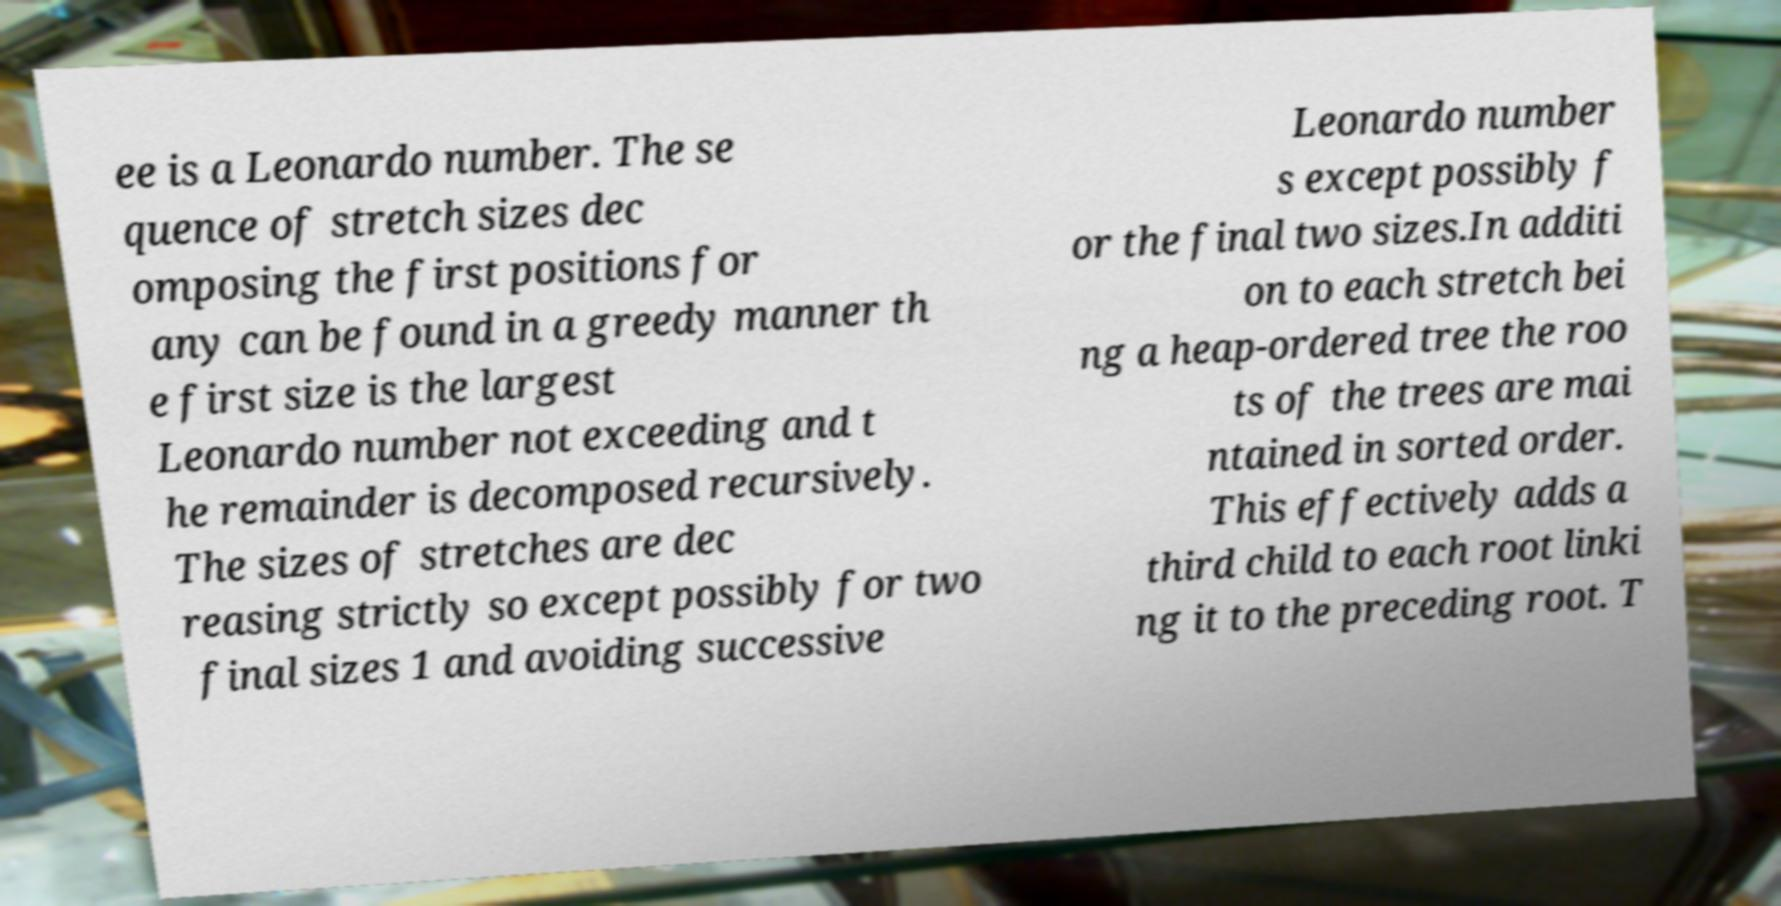Please identify and transcribe the text found in this image. ee is a Leonardo number. The se quence of stretch sizes dec omposing the first positions for any can be found in a greedy manner th e first size is the largest Leonardo number not exceeding and t he remainder is decomposed recursively. The sizes of stretches are dec reasing strictly so except possibly for two final sizes 1 and avoiding successive Leonardo number s except possibly f or the final two sizes.In additi on to each stretch bei ng a heap-ordered tree the roo ts of the trees are mai ntained in sorted order. This effectively adds a third child to each root linki ng it to the preceding root. T 